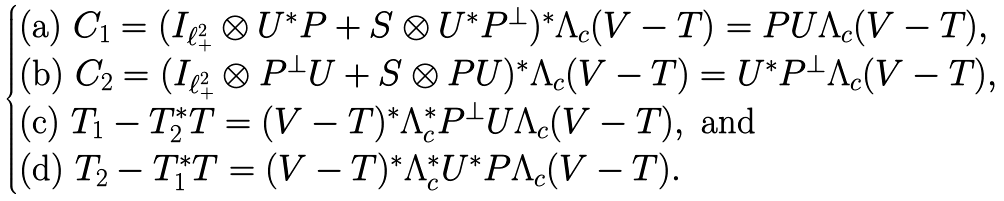Convert formula to latex. <formula><loc_0><loc_0><loc_500><loc_500>\begin{cases} \text {(a) } C _ { 1 } = ( I _ { \ell ^ { 2 } _ { + } } \otimes U ^ { * } P + S \otimes U ^ { * } P ^ { \perp } ) ^ { * } \Lambda _ { c } ( V - T ) = P U \Lambda _ { c } ( V - T ) , \\ \text {(b) } C _ { 2 } = ( I _ { \ell ^ { 2 } _ { + } } \otimes P ^ { \perp } U + S \otimes P U ) ^ { * } \Lambda _ { c } ( V - T ) = U ^ { * } P ^ { \perp } \Lambda _ { c } ( V - T ) , \\ \text {(c) } T _ { 1 } - T _ { 2 } ^ { * } T = ( V - T ) ^ { * } \Lambda _ { c } ^ { * } P ^ { \perp } U \Lambda _ { c } ( V - T ) , \text { and} \\ \text {(d) } T _ { 2 } - T _ { 1 } ^ { * } T = ( V - T ) ^ { * } \Lambda _ { c } ^ { * } U ^ { * } P \Lambda _ { c } ( V - T ) . \end{cases}</formula> 